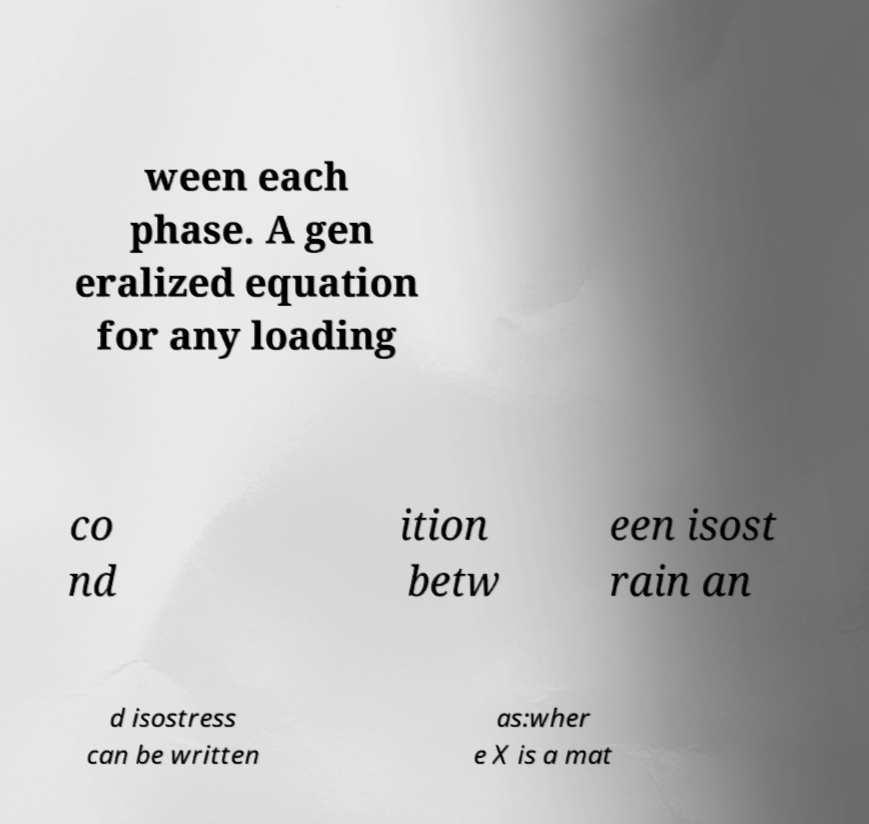Could you extract and type out the text from this image? ween each phase. A gen eralized equation for any loading co nd ition betw een isost rain an d isostress can be written as:wher e X is a mat 